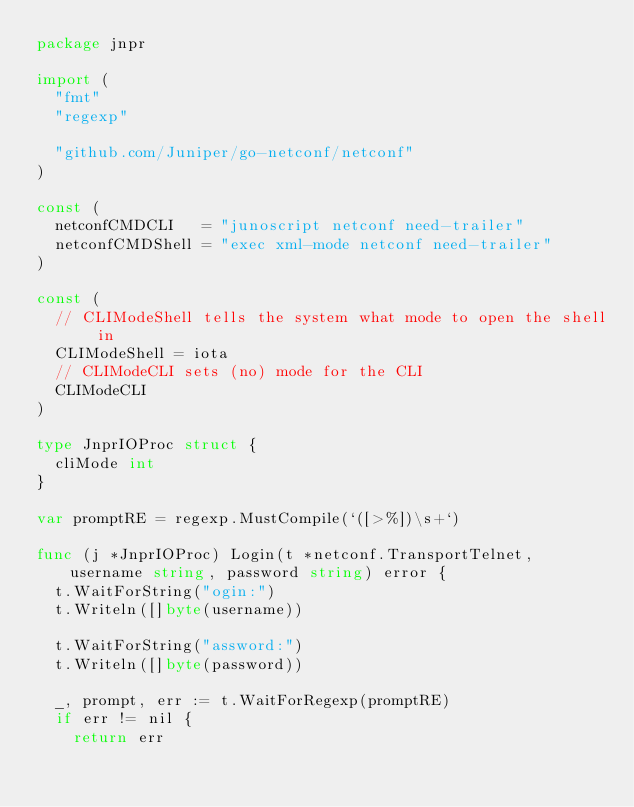Convert code to text. <code><loc_0><loc_0><loc_500><loc_500><_Go_>package jnpr

import (
	"fmt"
	"regexp"

	"github.com/Juniper/go-netconf/netconf"
)

const (
	netconfCMDCLI   = "junoscript netconf need-trailer"
	netconfCMDShell = "exec xml-mode netconf need-trailer"
)

const (
	// CLIModeShell tells the system what mode to open the shell in
	CLIModeShell = iota
	// CLIModeCLI sets (no) mode for the CLI
	CLIModeCLI
)

type JnprIOProc struct {
	cliMode int
}

var promptRE = regexp.MustCompile(`([>%])\s+`)

func (j *JnprIOProc) Login(t *netconf.TransportTelnet, username string, password string) error {
	t.WaitForString("ogin:")
	t.Writeln([]byte(username))

	t.WaitForString("assword:")
	t.Writeln([]byte(password))

	_, prompt, err := t.WaitForRegexp(promptRE)
	if err != nil {
		return err</code> 